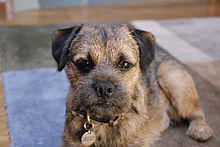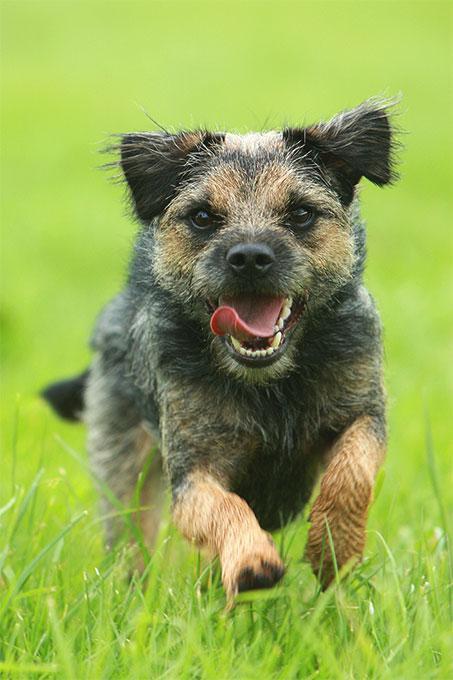The first image is the image on the left, the second image is the image on the right. Analyze the images presented: Is the assertion "One of the dogs is facing directly toward the left." valid? Answer yes or no. No. The first image is the image on the left, the second image is the image on the right. For the images shown, is this caption "At least one dog in the left image is looking towards the left." true? Answer yes or no. No. The first image is the image on the left, the second image is the image on the right. For the images shown, is this caption "A single dog is standing on all fours in the image on the left." true? Answer yes or no. No. 